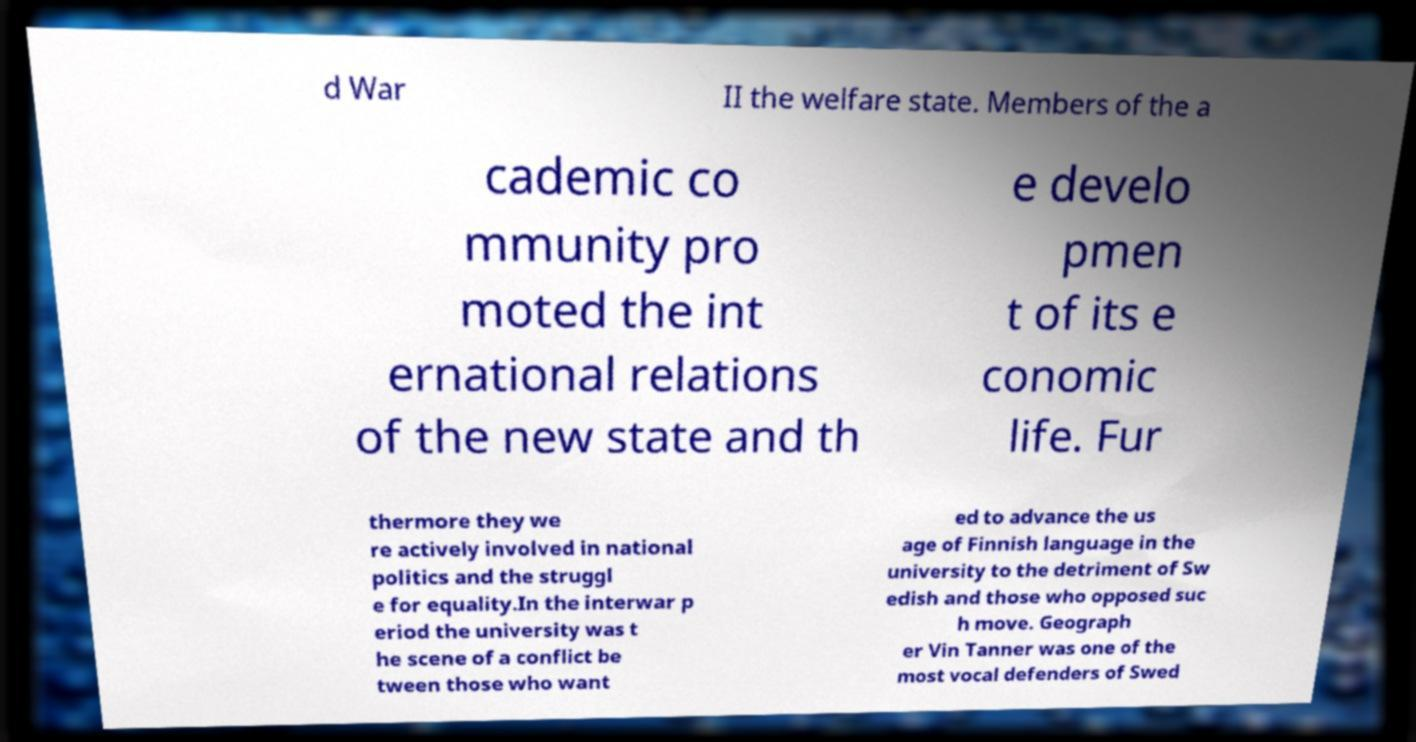Please identify and transcribe the text found in this image. d War II the welfare state. Members of the a cademic co mmunity pro moted the int ernational relations of the new state and th e develo pmen t of its e conomic life. Fur thermore they we re actively involved in national politics and the struggl e for equality.In the interwar p eriod the university was t he scene of a conflict be tween those who want ed to advance the us age of Finnish language in the university to the detriment of Sw edish and those who opposed suc h move. Geograph er Vin Tanner was one of the most vocal defenders of Swed 